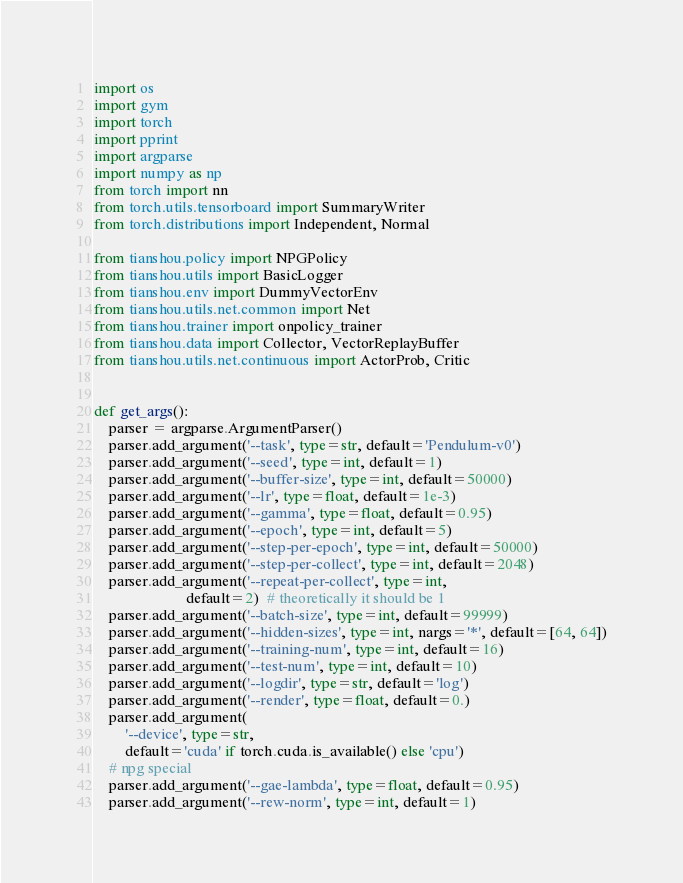<code> <loc_0><loc_0><loc_500><loc_500><_Python_>import os
import gym
import torch
import pprint
import argparse
import numpy as np
from torch import nn
from torch.utils.tensorboard import SummaryWriter
from torch.distributions import Independent, Normal

from tianshou.policy import NPGPolicy
from tianshou.utils import BasicLogger
from tianshou.env import DummyVectorEnv
from tianshou.utils.net.common import Net
from tianshou.trainer import onpolicy_trainer
from tianshou.data import Collector, VectorReplayBuffer
from tianshou.utils.net.continuous import ActorProb, Critic


def get_args():
    parser = argparse.ArgumentParser()
    parser.add_argument('--task', type=str, default='Pendulum-v0')
    parser.add_argument('--seed', type=int, default=1)
    parser.add_argument('--buffer-size', type=int, default=50000)
    parser.add_argument('--lr', type=float, default=1e-3)
    parser.add_argument('--gamma', type=float, default=0.95)
    parser.add_argument('--epoch', type=int, default=5)
    parser.add_argument('--step-per-epoch', type=int, default=50000)
    parser.add_argument('--step-per-collect', type=int, default=2048)
    parser.add_argument('--repeat-per-collect', type=int,
                        default=2)  # theoretically it should be 1
    parser.add_argument('--batch-size', type=int, default=99999)
    parser.add_argument('--hidden-sizes', type=int, nargs='*', default=[64, 64])
    parser.add_argument('--training-num', type=int, default=16)
    parser.add_argument('--test-num', type=int, default=10)
    parser.add_argument('--logdir', type=str, default='log')
    parser.add_argument('--render', type=float, default=0.)
    parser.add_argument(
        '--device', type=str,
        default='cuda' if torch.cuda.is_available() else 'cpu')
    # npg special
    parser.add_argument('--gae-lambda', type=float, default=0.95)
    parser.add_argument('--rew-norm', type=int, default=1)</code> 